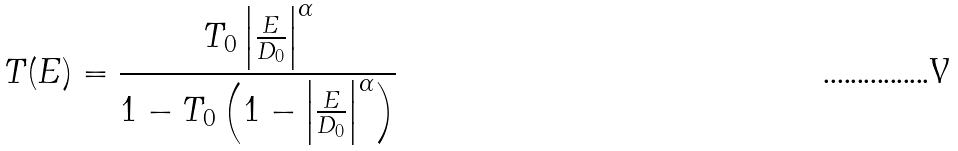Convert formula to latex. <formula><loc_0><loc_0><loc_500><loc_500>T ( E ) = \frac { T _ { 0 } \left | \frac { E } { D _ { 0 } } \right | ^ { \alpha } } { 1 - T _ { 0 } \left ( 1 - \left | \frac { E } { D _ { 0 } } \right | ^ { \alpha } \right ) }</formula> 